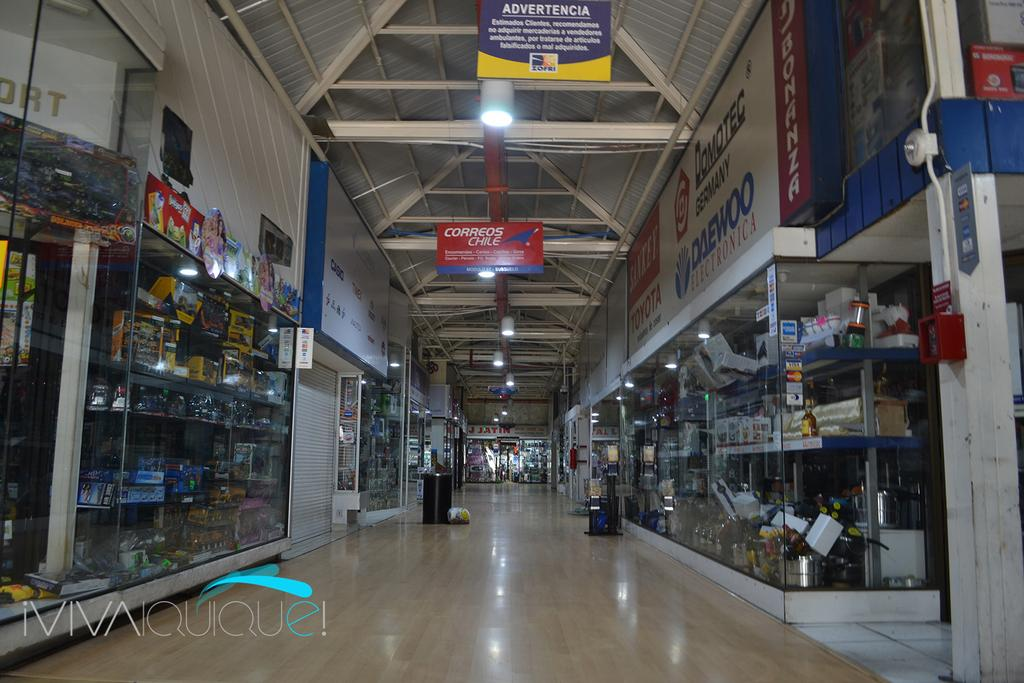<image>
Write a terse but informative summary of the picture. A shopping center with a sign advertising Correos Chile 